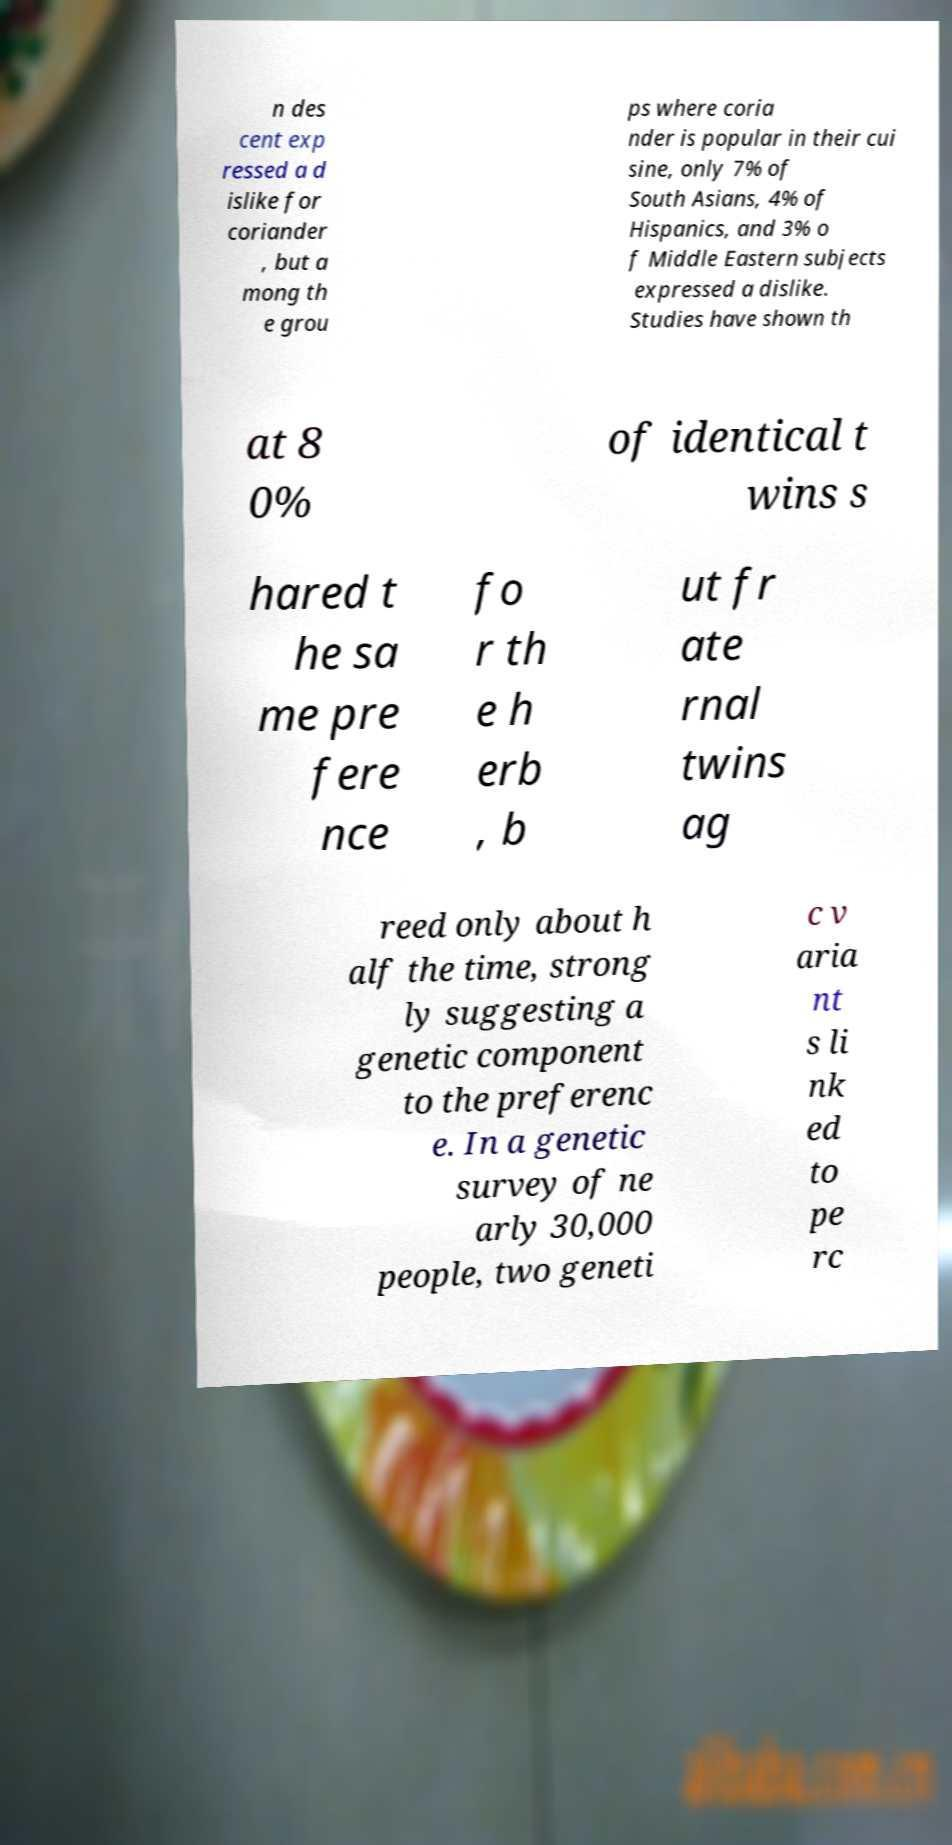Can you accurately transcribe the text from the provided image for me? n des cent exp ressed a d islike for coriander , but a mong th e grou ps where coria nder is popular in their cui sine, only 7% of South Asians, 4% of Hispanics, and 3% o f Middle Eastern subjects expressed a dislike. Studies have shown th at 8 0% of identical t wins s hared t he sa me pre fere nce fo r th e h erb , b ut fr ate rnal twins ag reed only about h alf the time, strong ly suggesting a genetic component to the preferenc e. In a genetic survey of ne arly 30,000 people, two geneti c v aria nt s li nk ed to pe rc 